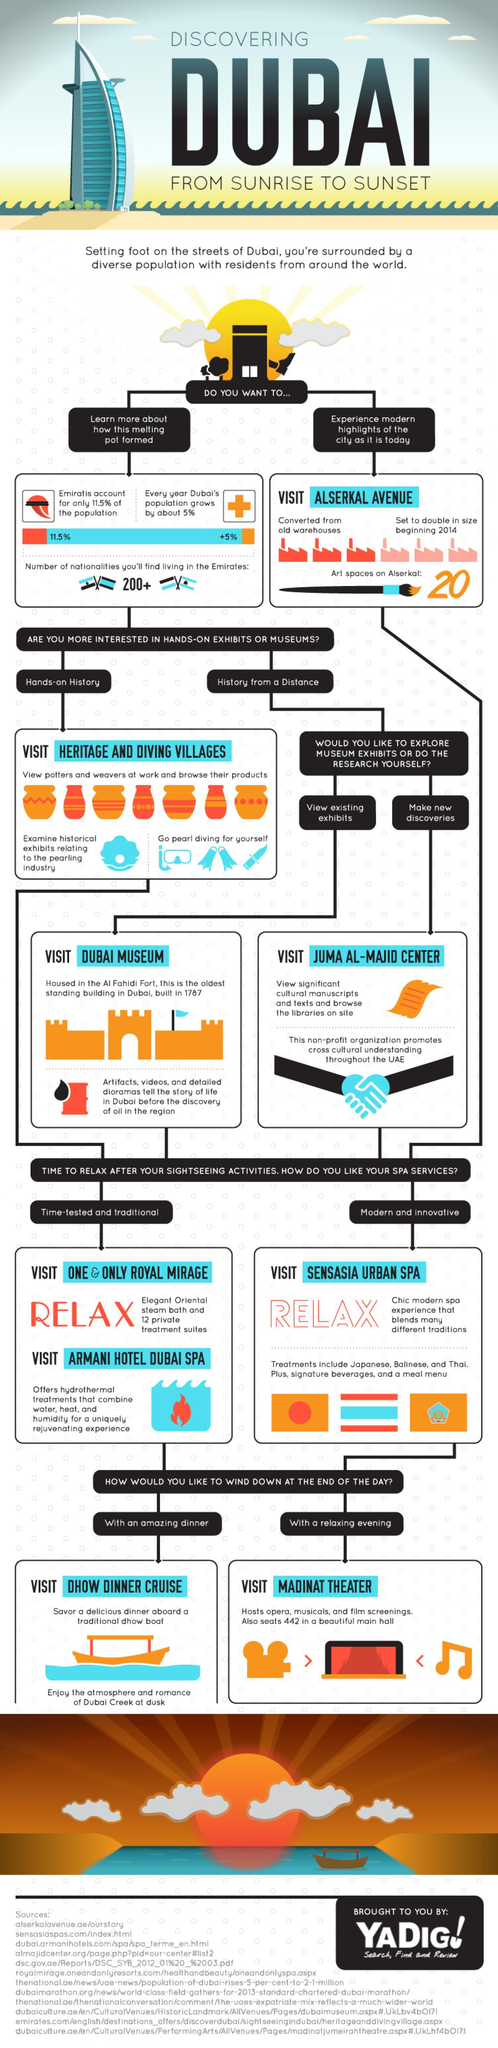Which place is best to visit in Dubai if one is interested in hands-on history?
Answer the question with a short phrase. Heritage and diving villages Which all are the two time-tested and traditional spas in Dubai? One & Only Royal Mirage, Armani hotel dubai spa Which place is best to visit in Dubai if one is interested in viewing existing exhibits? Dubai Museum What is the name of the modern and innovative spa in Dubai? Sensasia urban spa What are the two different types of spa services? Time-tested and traditional, Modern and innovative What is the name of a dinner space in Dubai? Dhow dinner cruise Which place is best to visit in Dubai if one is interested in making new discoveries? Juma al-majid center 